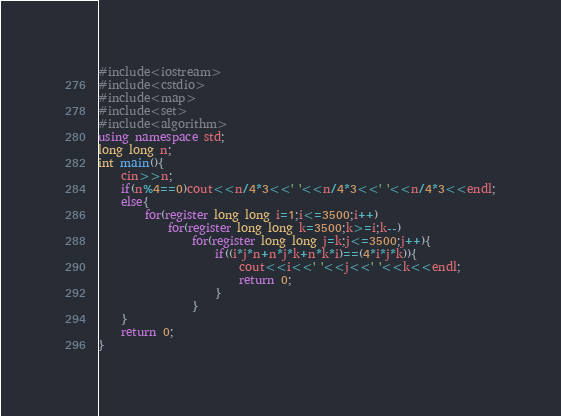Convert code to text. <code><loc_0><loc_0><loc_500><loc_500><_C++_>#include<iostream>
#include<cstdio>
#include<map>
#include<set>
#include<algorithm>
using namespace std;
long long n;
int main(){
	cin>>n;
	if(n%4==0)cout<<n/4*3<<' '<<n/4*3<<' '<<n/4*3<<endl;
	else{
		for(register long long i=1;i<=3500;i++)
			for(register long long k=3500;k>=i;k--)
				for(register long long j=k;j<=3500;j++){
					if((i*j*n+n*j*k+n*k*i)==(4*i*j*k)){
						cout<<i<<' '<<j<<' '<<k<<endl;
						return 0;
					}
				}
	}
	return 0;
}</code> 